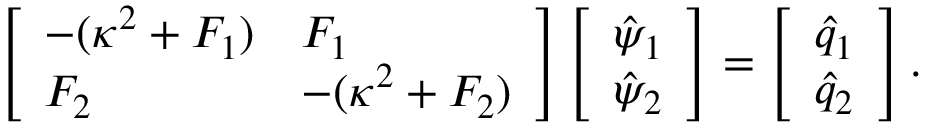Convert formula to latex. <formula><loc_0><loc_0><loc_500><loc_500>\left [ \begin{array} { l l } { - ( \kappa ^ { 2 } + F _ { 1 } ) } & { F _ { 1 } } \\ { F _ { 2 } } & { - ( \kappa ^ { 2 } + F _ { 2 } ) } \end{array} \right ] \left [ \begin{array} { l } { \hat { \psi } _ { 1 } } \\ { \hat { \psi } _ { 2 } } \end{array} \right ] = \left [ \begin{array} { l } { \hat { q } _ { 1 } } \\ { \hat { q } _ { 2 } } \end{array} \right ] .</formula> 